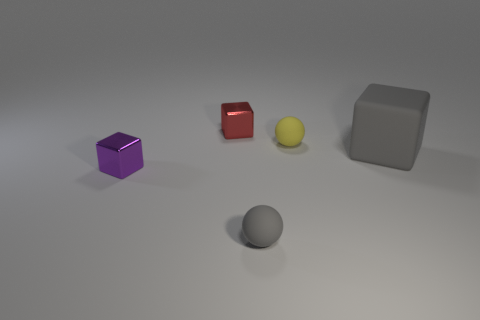How many spheres are behind the purple metal cube? There is one sphere situated behind the purple metal cube, and it appears to be of a neutral grey tone, seamlessly blending into the subtle shadows of the background. 